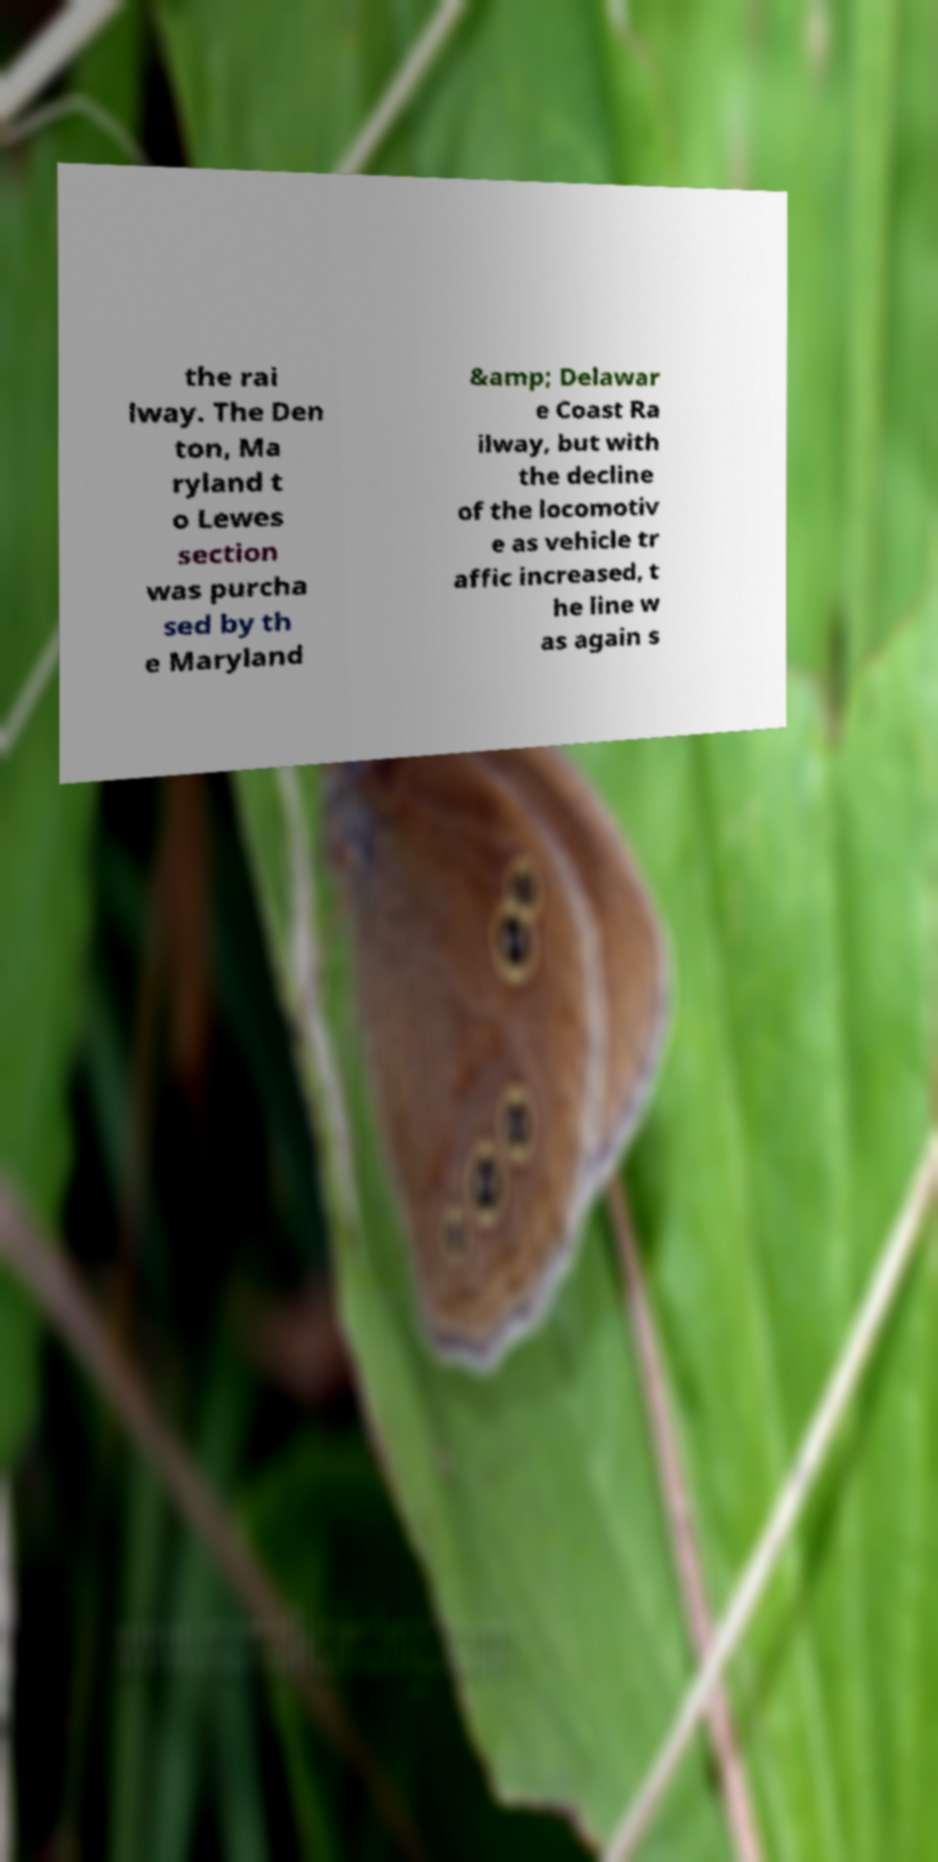Please read and relay the text visible in this image. What does it say? the rai lway. The Den ton, Ma ryland t o Lewes section was purcha sed by th e Maryland &amp; Delawar e Coast Ra ilway, but with the decline of the locomotiv e as vehicle tr affic increased, t he line w as again s 